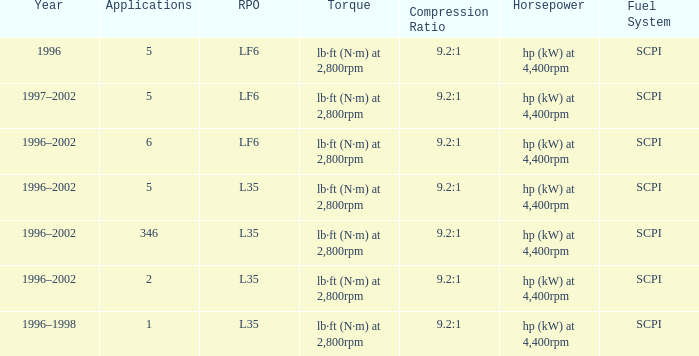What are the torque characteristics of the model made in 1996? Lb·ft (n·m) at 2,800rpm. 